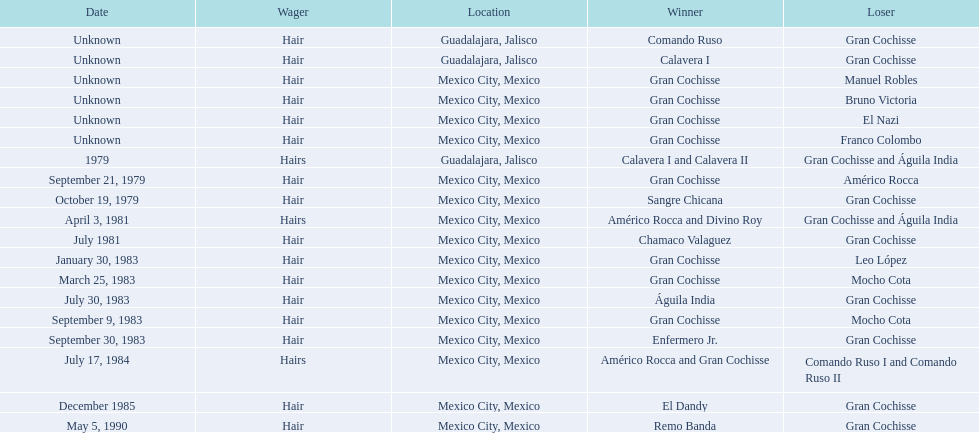How many times has the wager been hair? 16. 